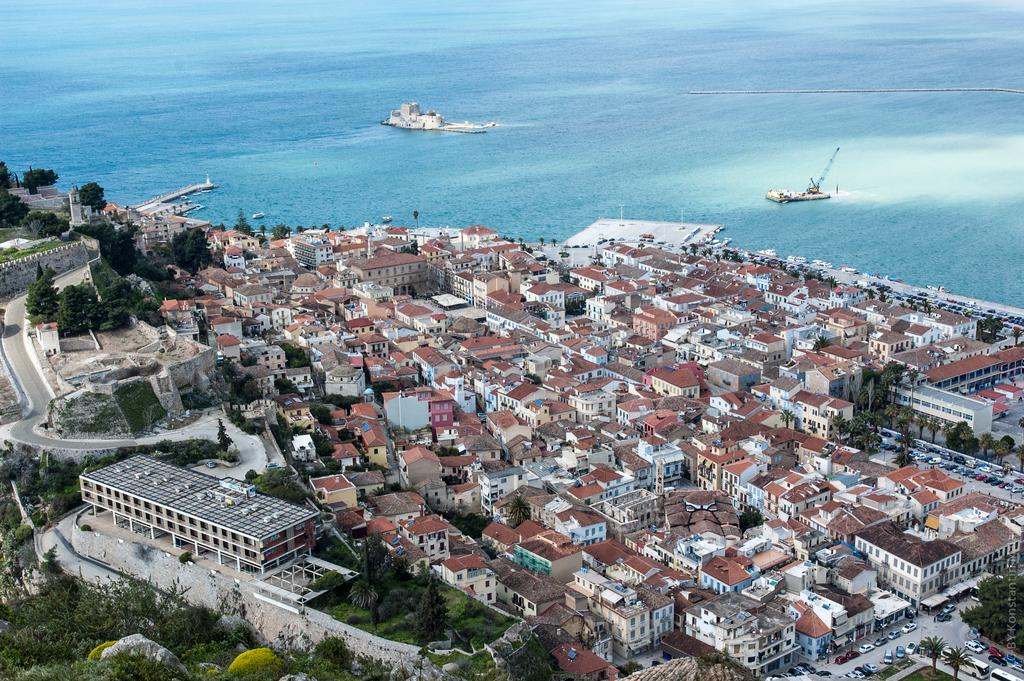What type of vegetation can be seen in the image? There are groups of trees in the image. What type of structures are present in the image? There are houses in the image. What natural element is visible in the background of the image? There is a water surface visible in the background of the image. What type of education can be seen taking place in the image? There is no indication of any educational activities taking place in the image. How many lizards can be seen in the image? There are no lizards present in the image. 